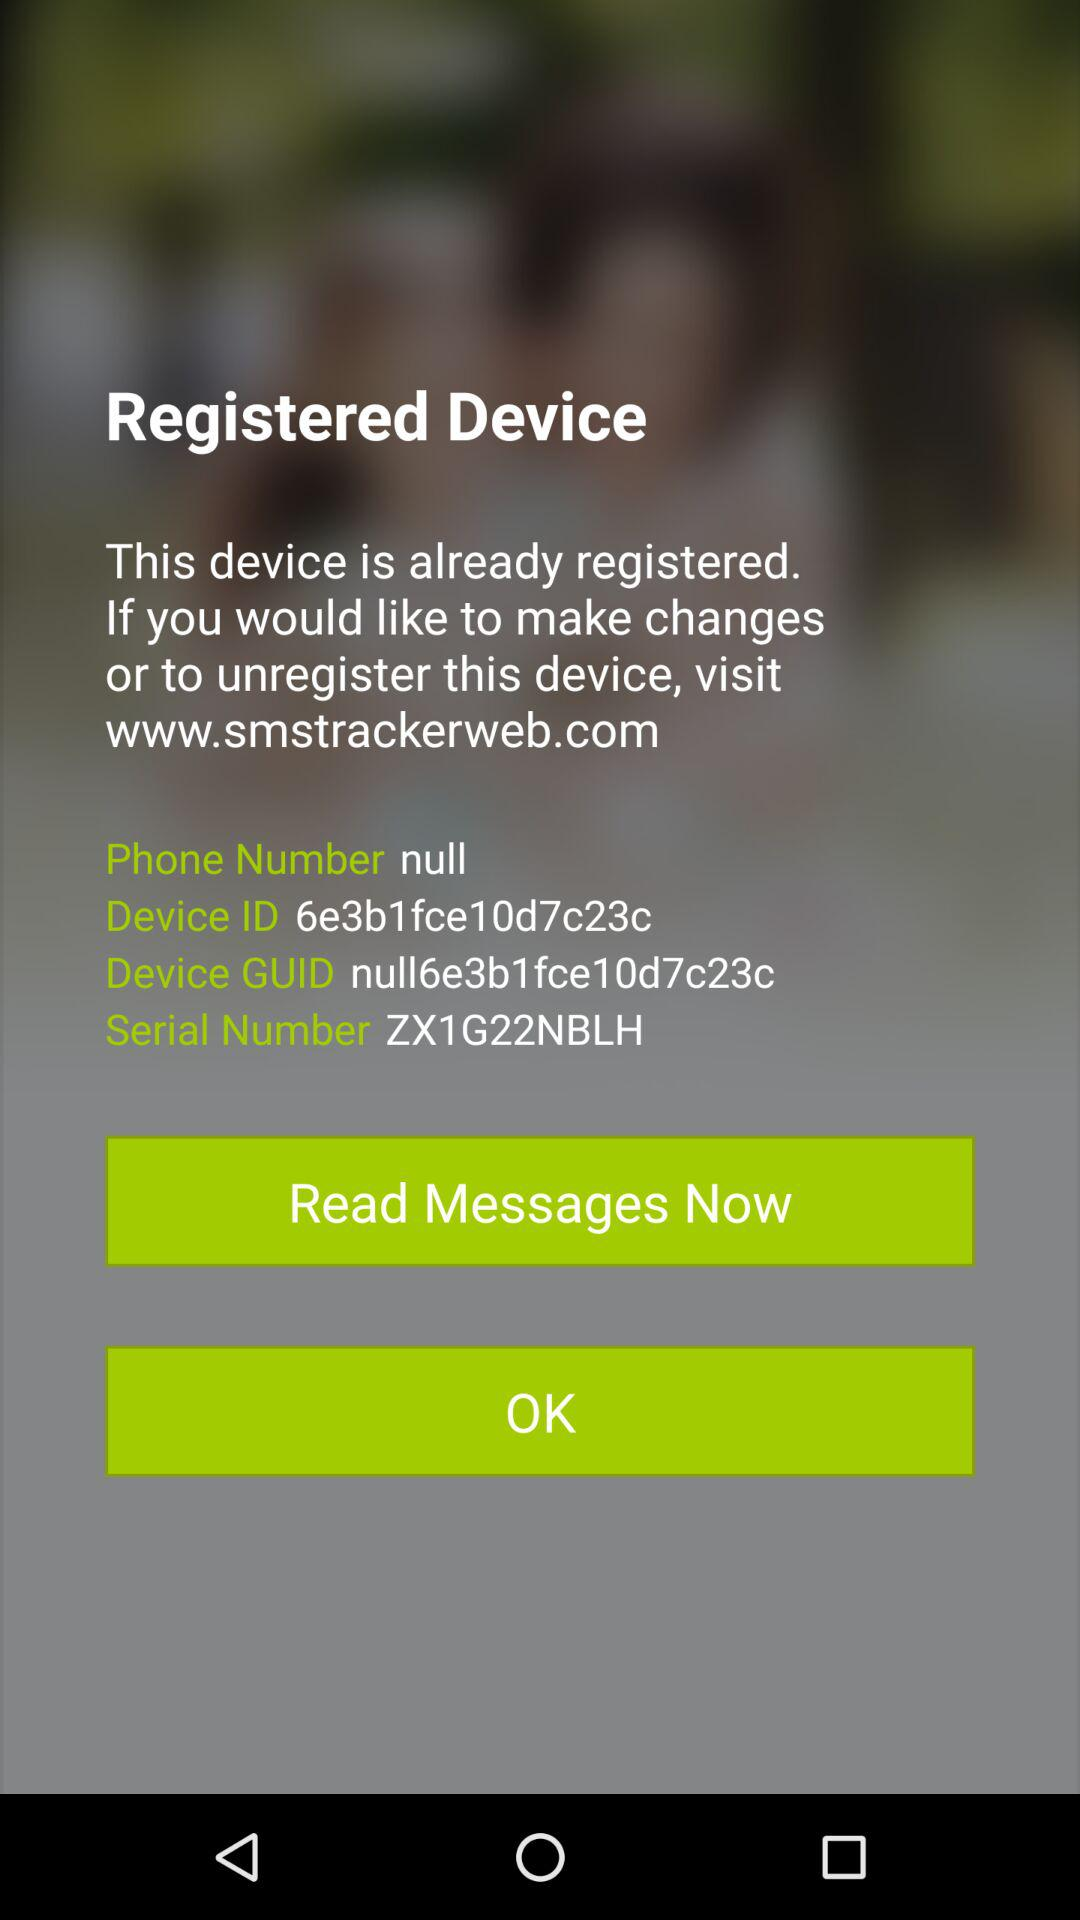What is the device ID? The device ID is 6e3b1fce10d7c23c. 